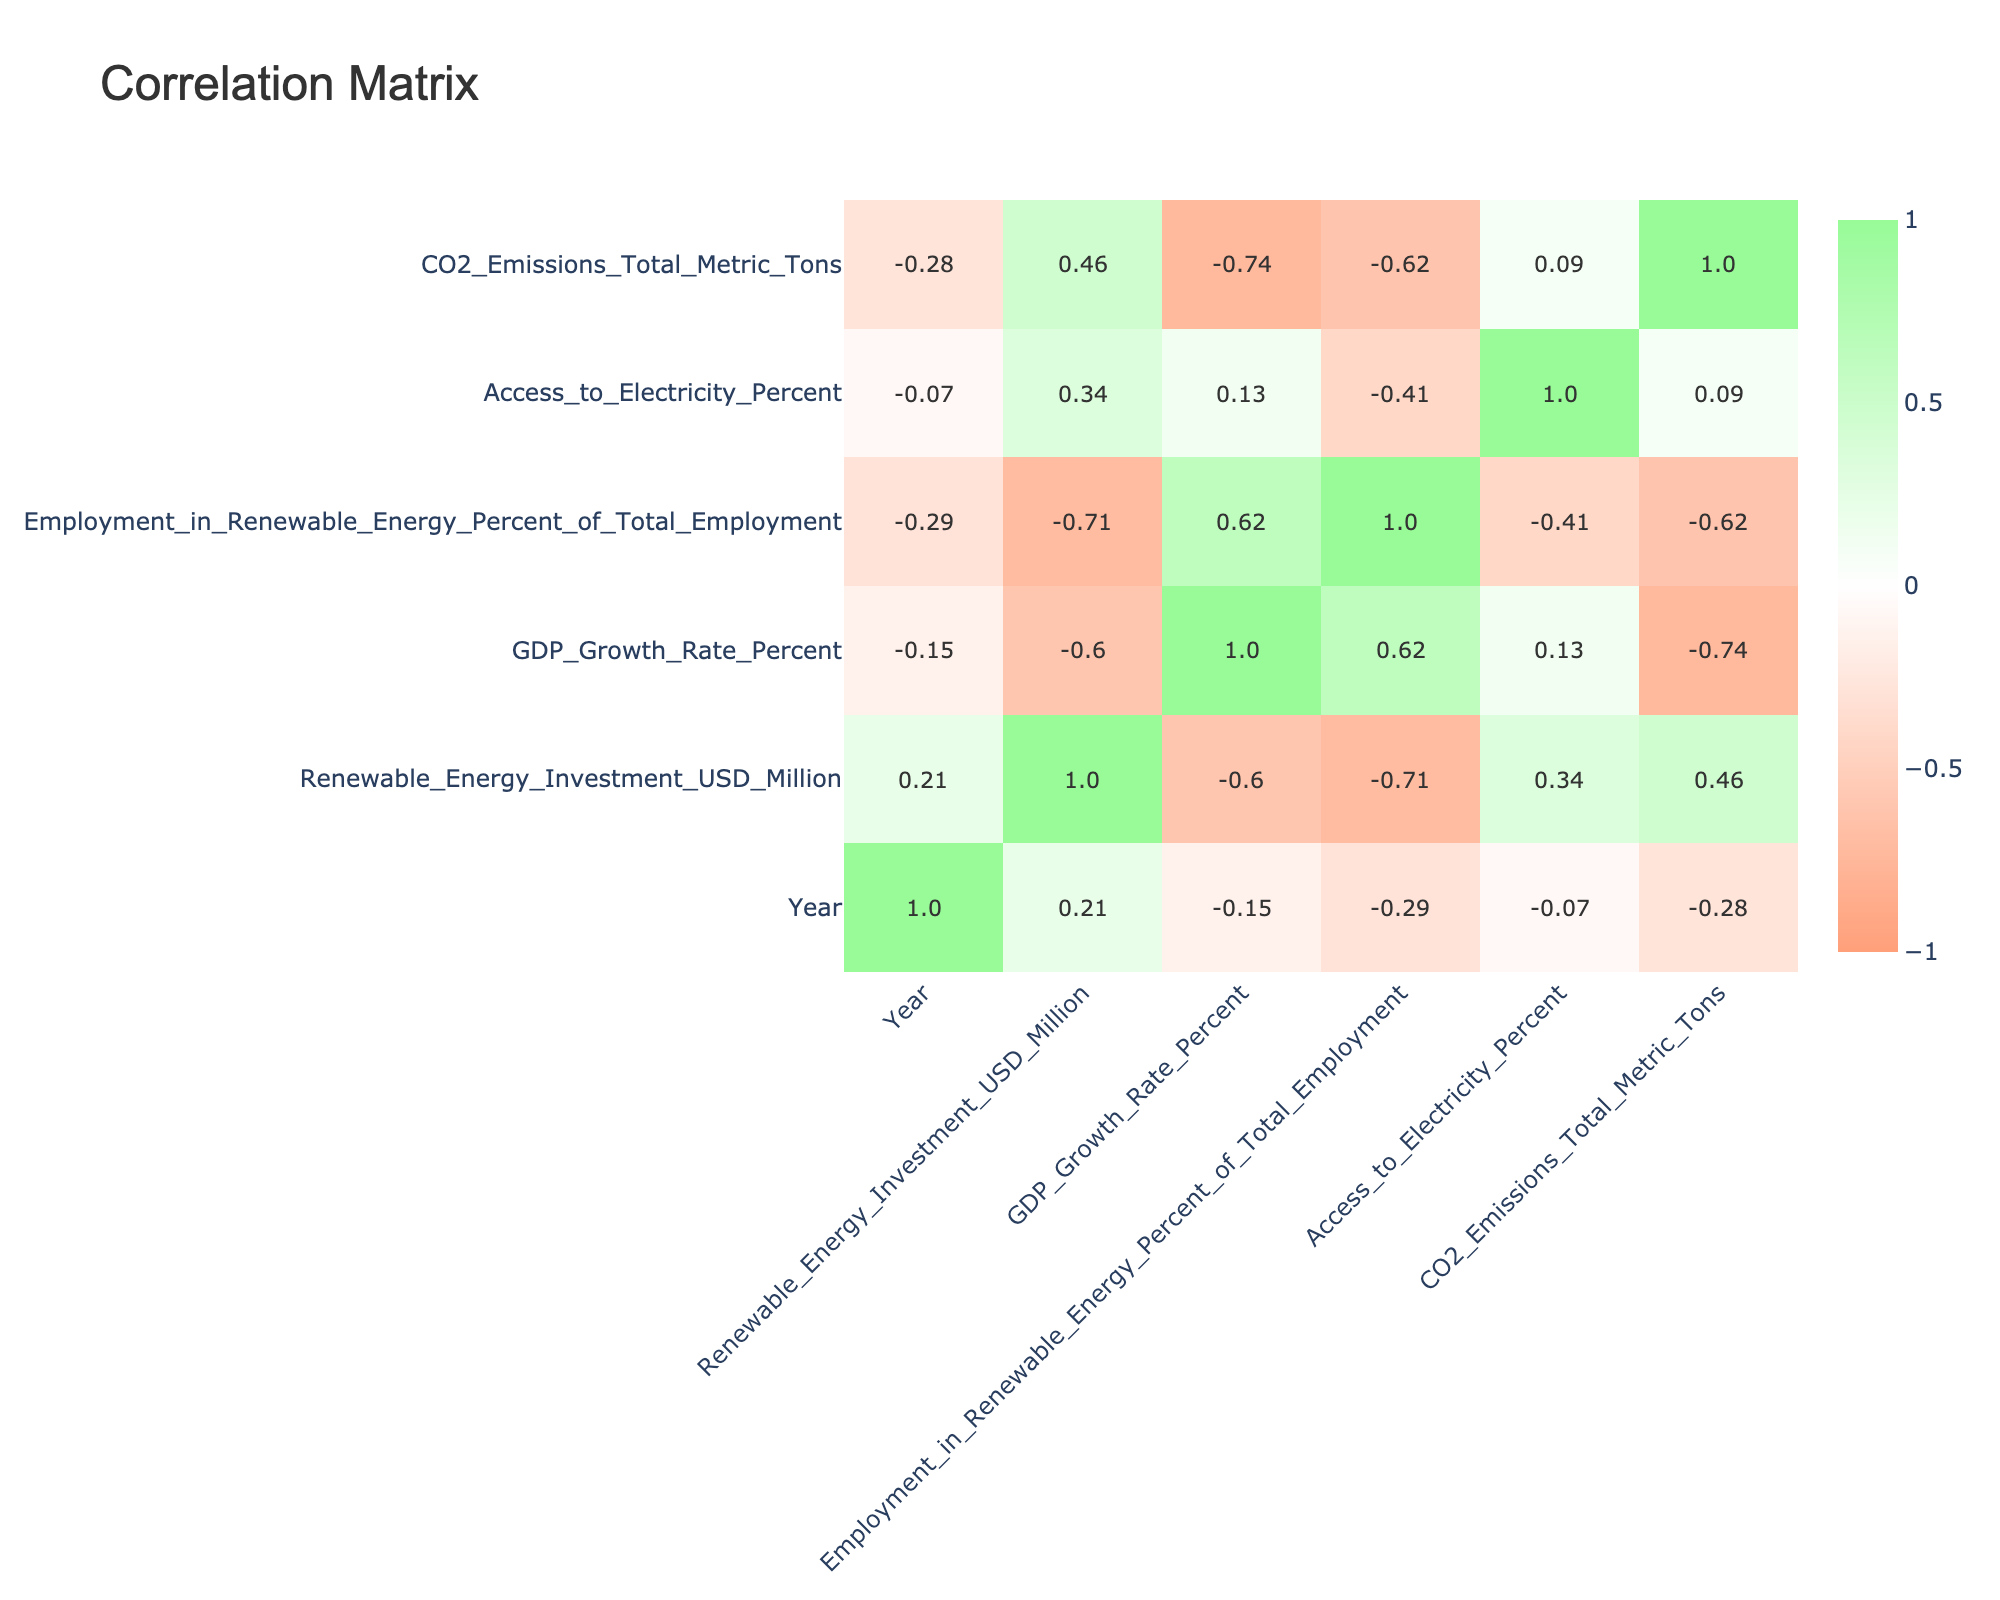What is the GDP growth rate for Kenya in 2020? The table shows the GDP growth rate for Kenya in the Year 2020 directly. Looking at the row for Kenya and the specified year, the value is clearly listed as 5.4 percent.
Answer: 5.4 percent Is the total CO2 emissions for Morocco higher than that for Bangladesh? By examining the rows for both Morocco and Bangladesh, we find that Morocco has total CO2 emissions of 0.6 metric tons, while Bangladesh has 0.9 metric tons. Since 0.6 is less than 0.9, the emissions for Morocco are not higher than Bangladesh's.
Answer: No What is the average renewable energy investment for the countries listed in 2020? We calculate the average for 2020's renewable energy investments by summing the investments: (9300 + 511 + 12200 + 1200 + 900) = 20011 million USD. There are 5 data points for 2020, so the average is 20011/5 = 4002.2 million USD.
Answer: 4002.2 million USD Does South Africa have more employment in renewable energy as a percentage of total employment than Brazil? South Africa's percentage of employment in renewable energy is 1.0 percent, while Brazil's is 0.8 percent. Since 1.0 is greater than 0.8, it means South Africa has a higher employment percentage in renewable energy compared to Brazil.
Answer: Yes Which country has the highest investment in renewable energy among those listed? To determine which country has the highest investment, we can look at the renewable energy investment figures. Comparing all investments, Brazil, with an investment of 12,200 million USD, is the highest among the listed countries for 2020.
Answer: Brazil 